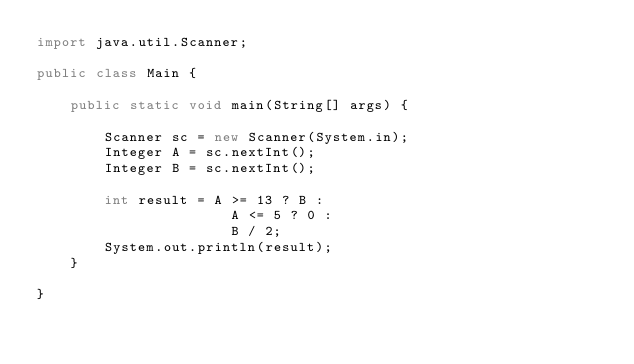Convert code to text. <code><loc_0><loc_0><loc_500><loc_500><_Java_>import java.util.Scanner;

public class Main {

    public static void main(String[] args) {

        Scanner sc = new Scanner(System.in);
        Integer A = sc.nextInt();
        Integer B = sc.nextInt();

        int result = A >= 13 ? B :
                       A <= 5 ? 0 :
                       B / 2;
        System.out.println(result);
    }

}
</code> 